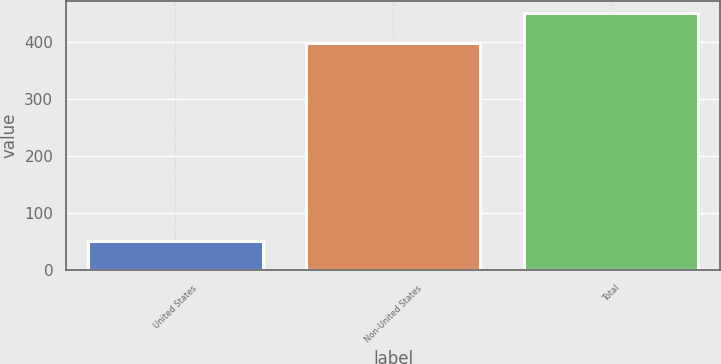Convert chart. <chart><loc_0><loc_0><loc_500><loc_500><bar_chart><fcel>United States<fcel>Non-United States<fcel>Total<nl><fcel>51<fcel>399<fcel>450<nl></chart> 